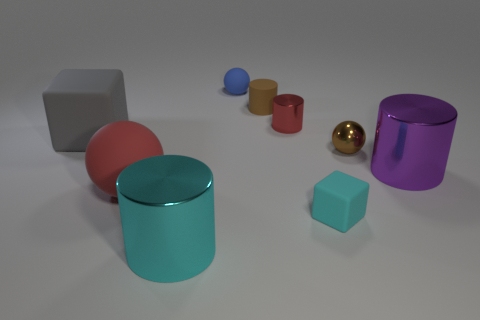There is a ball that is behind the shiny cylinder behind the large cylinder to the right of the tiny brown sphere; what color is it?
Ensure brevity in your answer.  Blue. Does the red shiny object have the same shape as the gray rubber thing?
Your answer should be compact. No. The large cylinder that is made of the same material as the big purple object is what color?
Give a very brief answer. Cyan. How many things are objects to the right of the blue sphere or purple shiny objects?
Offer a terse response. 5. There is a cylinder that is in front of the cyan block; how big is it?
Offer a terse response. Large. There is a cyan matte block; is its size the same as the red ball that is left of the metal ball?
Provide a short and direct response. No. There is a cylinder in front of the big metal object that is behind the red ball; what color is it?
Provide a short and direct response. Cyan. What number of other objects are there of the same color as the metallic sphere?
Make the answer very short. 1. How big is the cyan metal cylinder?
Provide a succinct answer. Large. Is the number of spheres to the left of the small red thing greater than the number of brown rubber cylinders that are to the left of the matte cylinder?
Give a very brief answer. Yes. 